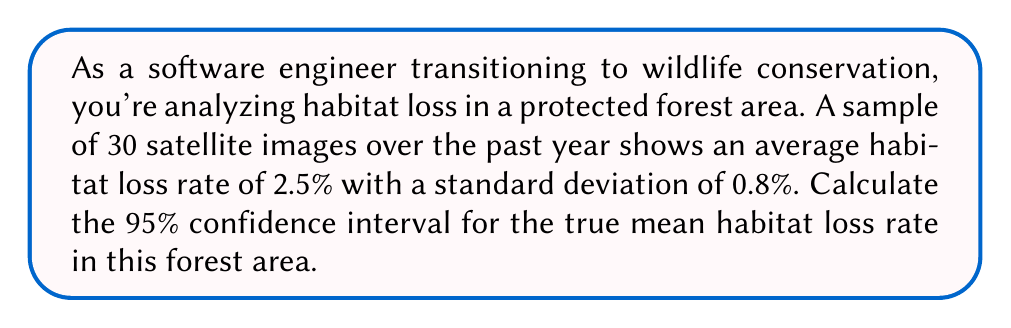What is the answer to this math problem? To calculate the confidence interval, we'll follow these steps:

1) The formula for a confidence interval is:

   $$\bar{x} \pm t_{\alpha/2} \cdot \frac{s}{\sqrt{n}}$$

   Where:
   $\bar{x}$ is the sample mean
   $t_{\alpha/2}$ is the t-value for the desired confidence level
   $s$ is the sample standard deviation
   $n$ is the sample size

2) We know:
   $\bar{x} = 2.5\%$
   $s = 0.8\%$
   $n = 30$
   Confidence level = 95%, so $\alpha = 0.05$

3) For a 95% confidence interval with 29 degrees of freedom (n-1), the t-value is approximately 2.045 (from t-distribution table).

4) Plugging into the formula:

   $$2.5\% \pm 2.045 \cdot \frac{0.8\%}{\sqrt{30}}$$

5) Simplify:
   $$2.5\% \pm 2.045 \cdot 0.146\%$$
   $$2.5\% \pm 0.299\%$$

6) Therefore, the confidence interval is:
   $$(2.5\% - 0.299\%, 2.5\% + 0.299\%)$$
   $$(2.201\%, 2.799\%)$$
Answer: (2.201%, 2.799%) 